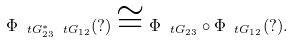<formula> <loc_0><loc_0><loc_500><loc_500>\Phi _ { \ t G _ { 2 3 } ^ { * } \ t G _ { 1 2 } } ( ? ) \cong \Phi _ { \ t G _ { 2 3 } } \circ \Phi _ { \ t G _ { 1 2 } } ( ? ) .</formula> 